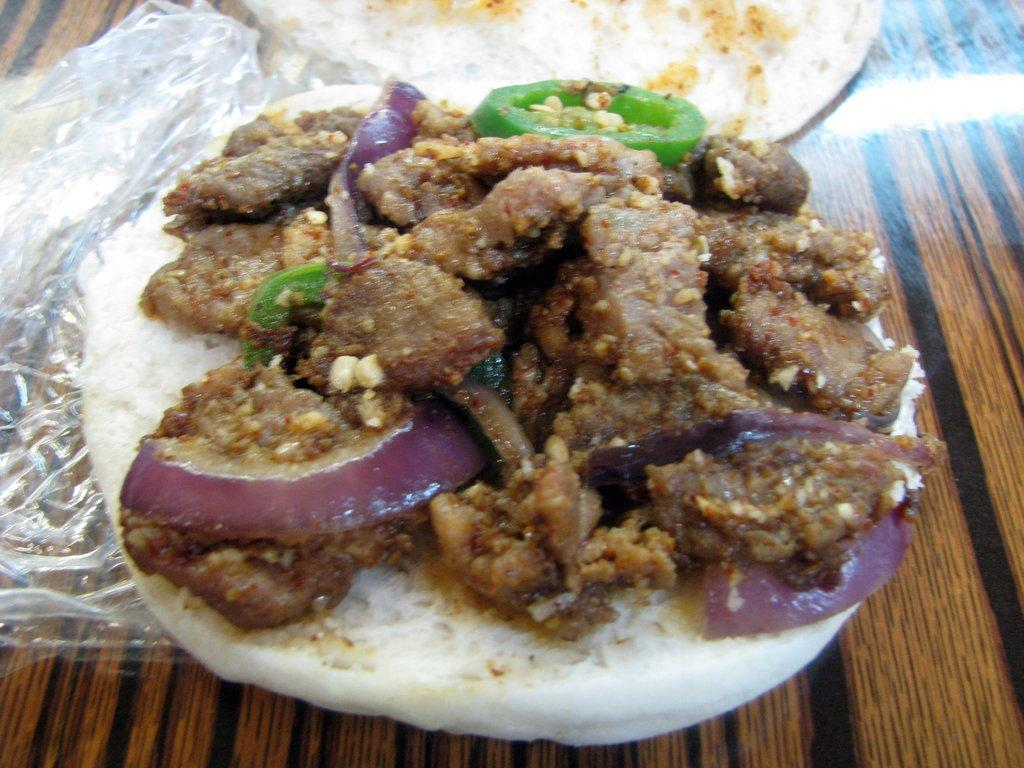What is present on the table in the image? There is food and a cover on the table in the image. What is the purpose of the cover in the image? The purpose of the cover is not explicitly stated, but it may be used to protect or conceal the food. Can you describe the type of food in the image? The type of food is not specified in the facts provided. Is there a button on the table in the image? There is no mention of a button in the image, so we cannot confirm its presence. 